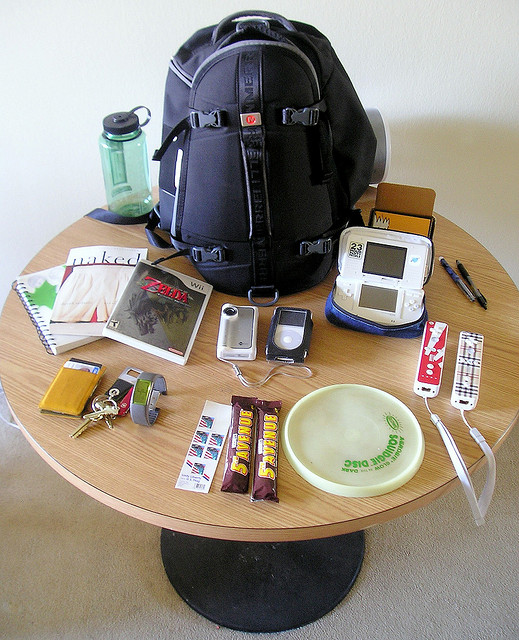Read and extract the text from this image. naked 5 AVENUE AVENUE 23 MOJO DISC 